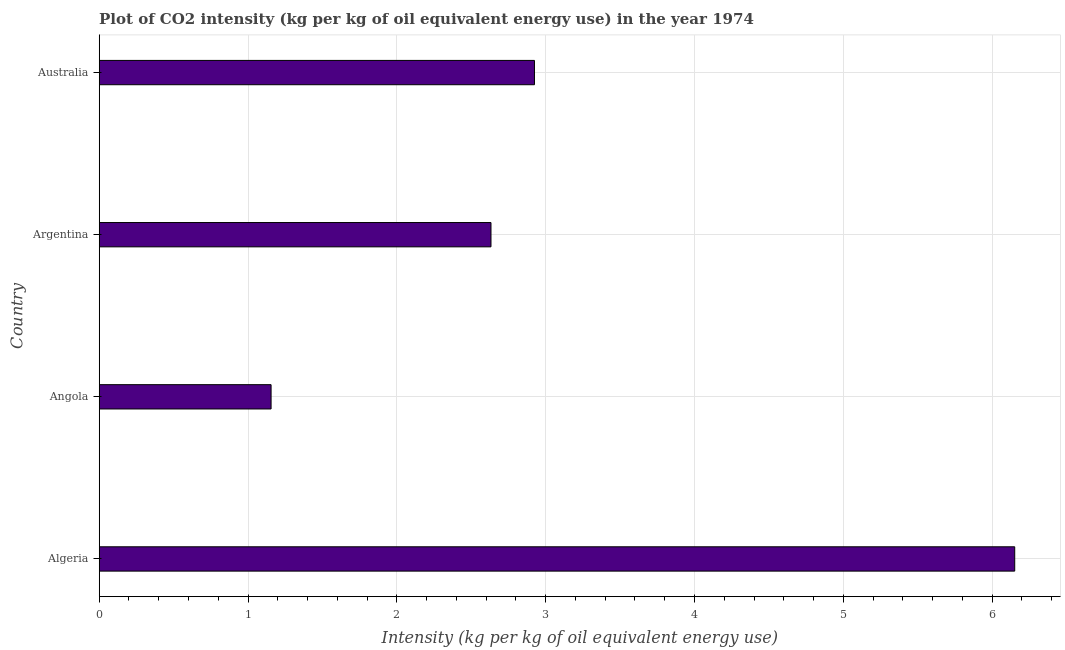Does the graph contain any zero values?
Keep it short and to the point. No. What is the title of the graph?
Provide a succinct answer. Plot of CO2 intensity (kg per kg of oil equivalent energy use) in the year 1974. What is the label or title of the X-axis?
Keep it short and to the point. Intensity (kg per kg of oil equivalent energy use). What is the co2 intensity in Argentina?
Ensure brevity in your answer.  2.63. Across all countries, what is the maximum co2 intensity?
Your answer should be compact. 6.15. Across all countries, what is the minimum co2 intensity?
Provide a short and direct response. 1.15. In which country was the co2 intensity maximum?
Provide a succinct answer. Algeria. In which country was the co2 intensity minimum?
Keep it short and to the point. Angola. What is the sum of the co2 intensity?
Your response must be concise. 12.86. What is the difference between the co2 intensity in Argentina and Australia?
Provide a succinct answer. -0.29. What is the average co2 intensity per country?
Your answer should be very brief. 3.22. What is the median co2 intensity?
Offer a terse response. 2.78. What is the ratio of the co2 intensity in Algeria to that in Argentina?
Make the answer very short. 2.34. What is the difference between the highest and the second highest co2 intensity?
Your answer should be compact. 3.23. What is the difference between the highest and the lowest co2 intensity?
Your response must be concise. 5. In how many countries, is the co2 intensity greater than the average co2 intensity taken over all countries?
Offer a very short reply. 1. Are the values on the major ticks of X-axis written in scientific E-notation?
Offer a very short reply. No. What is the Intensity (kg per kg of oil equivalent energy use) of Algeria?
Your answer should be compact. 6.15. What is the Intensity (kg per kg of oil equivalent energy use) of Angola?
Provide a short and direct response. 1.15. What is the Intensity (kg per kg of oil equivalent energy use) of Argentina?
Ensure brevity in your answer.  2.63. What is the Intensity (kg per kg of oil equivalent energy use) in Australia?
Offer a very short reply. 2.92. What is the difference between the Intensity (kg per kg of oil equivalent energy use) in Algeria and Angola?
Provide a short and direct response. 5. What is the difference between the Intensity (kg per kg of oil equivalent energy use) in Algeria and Argentina?
Your answer should be very brief. 3.52. What is the difference between the Intensity (kg per kg of oil equivalent energy use) in Algeria and Australia?
Offer a very short reply. 3.23. What is the difference between the Intensity (kg per kg of oil equivalent energy use) in Angola and Argentina?
Offer a very short reply. -1.48. What is the difference between the Intensity (kg per kg of oil equivalent energy use) in Angola and Australia?
Provide a succinct answer. -1.77. What is the difference between the Intensity (kg per kg of oil equivalent energy use) in Argentina and Australia?
Ensure brevity in your answer.  -0.29. What is the ratio of the Intensity (kg per kg of oil equivalent energy use) in Algeria to that in Angola?
Your response must be concise. 5.33. What is the ratio of the Intensity (kg per kg of oil equivalent energy use) in Algeria to that in Argentina?
Make the answer very short. 2.34. What is the ratio of the Intensity (kg per kg of oil equivalent energy use) in Algeria to that in Australia?
Make the answer very short. 2.1. What is the ratio of the Intensity (kg per kg of oil equivalent energy use) in Angola to that in Argentina?
Ensure brevity in your answer.  0.44. What is the ratio of the Intensity (kg per kg of oil equivalent energy use) in Angola to that in Australia?
Your response must be concise. 0.4. 